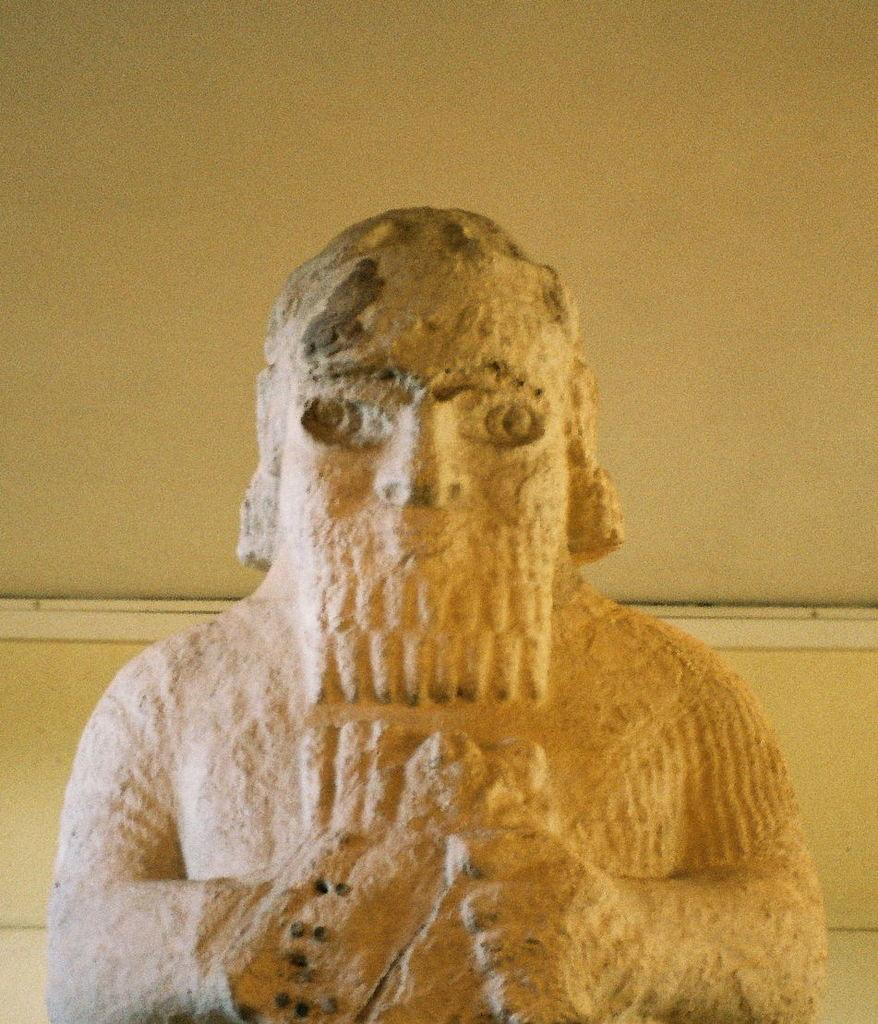What is the main subject in the image? There is a statue in the image. Can you describe the background of the image? There is a well in the background of the image. How many chickens are running around the statue in the image? There are no chickens present in the image; it only features a statue and a well in the background. 